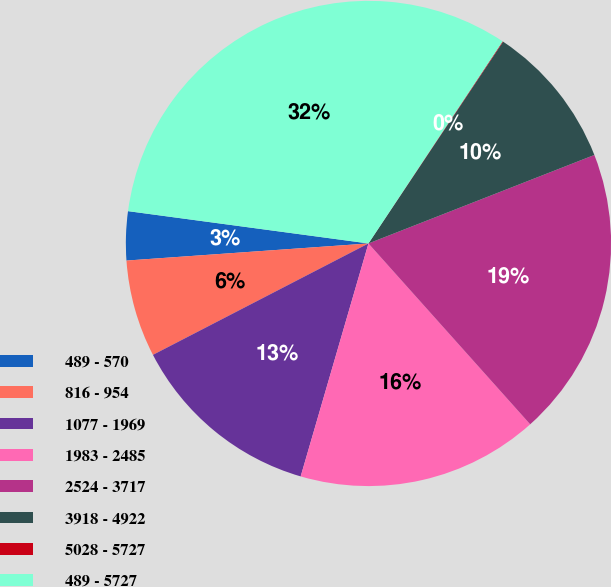Convert chart to OTSL. <chart><loc_0><loc_0><loc_500><loc_500><pie_chart><fcel>489 - 570<fcel>816 - 954<fcel>1077 - 1969<fcel>1983 - 2485<fcel>2524 - 3717<fcel>3918 - 4922<fcel>5028 - 5727<fcel>489 - 5727<nl><fcel>3.25%<fcel>6.47%<fcel>12.9%<fcel>16.12%<fcel>19.33%<fcel>9.69%<fcel>0.04%<fcel>32.2%<nl></chart> 